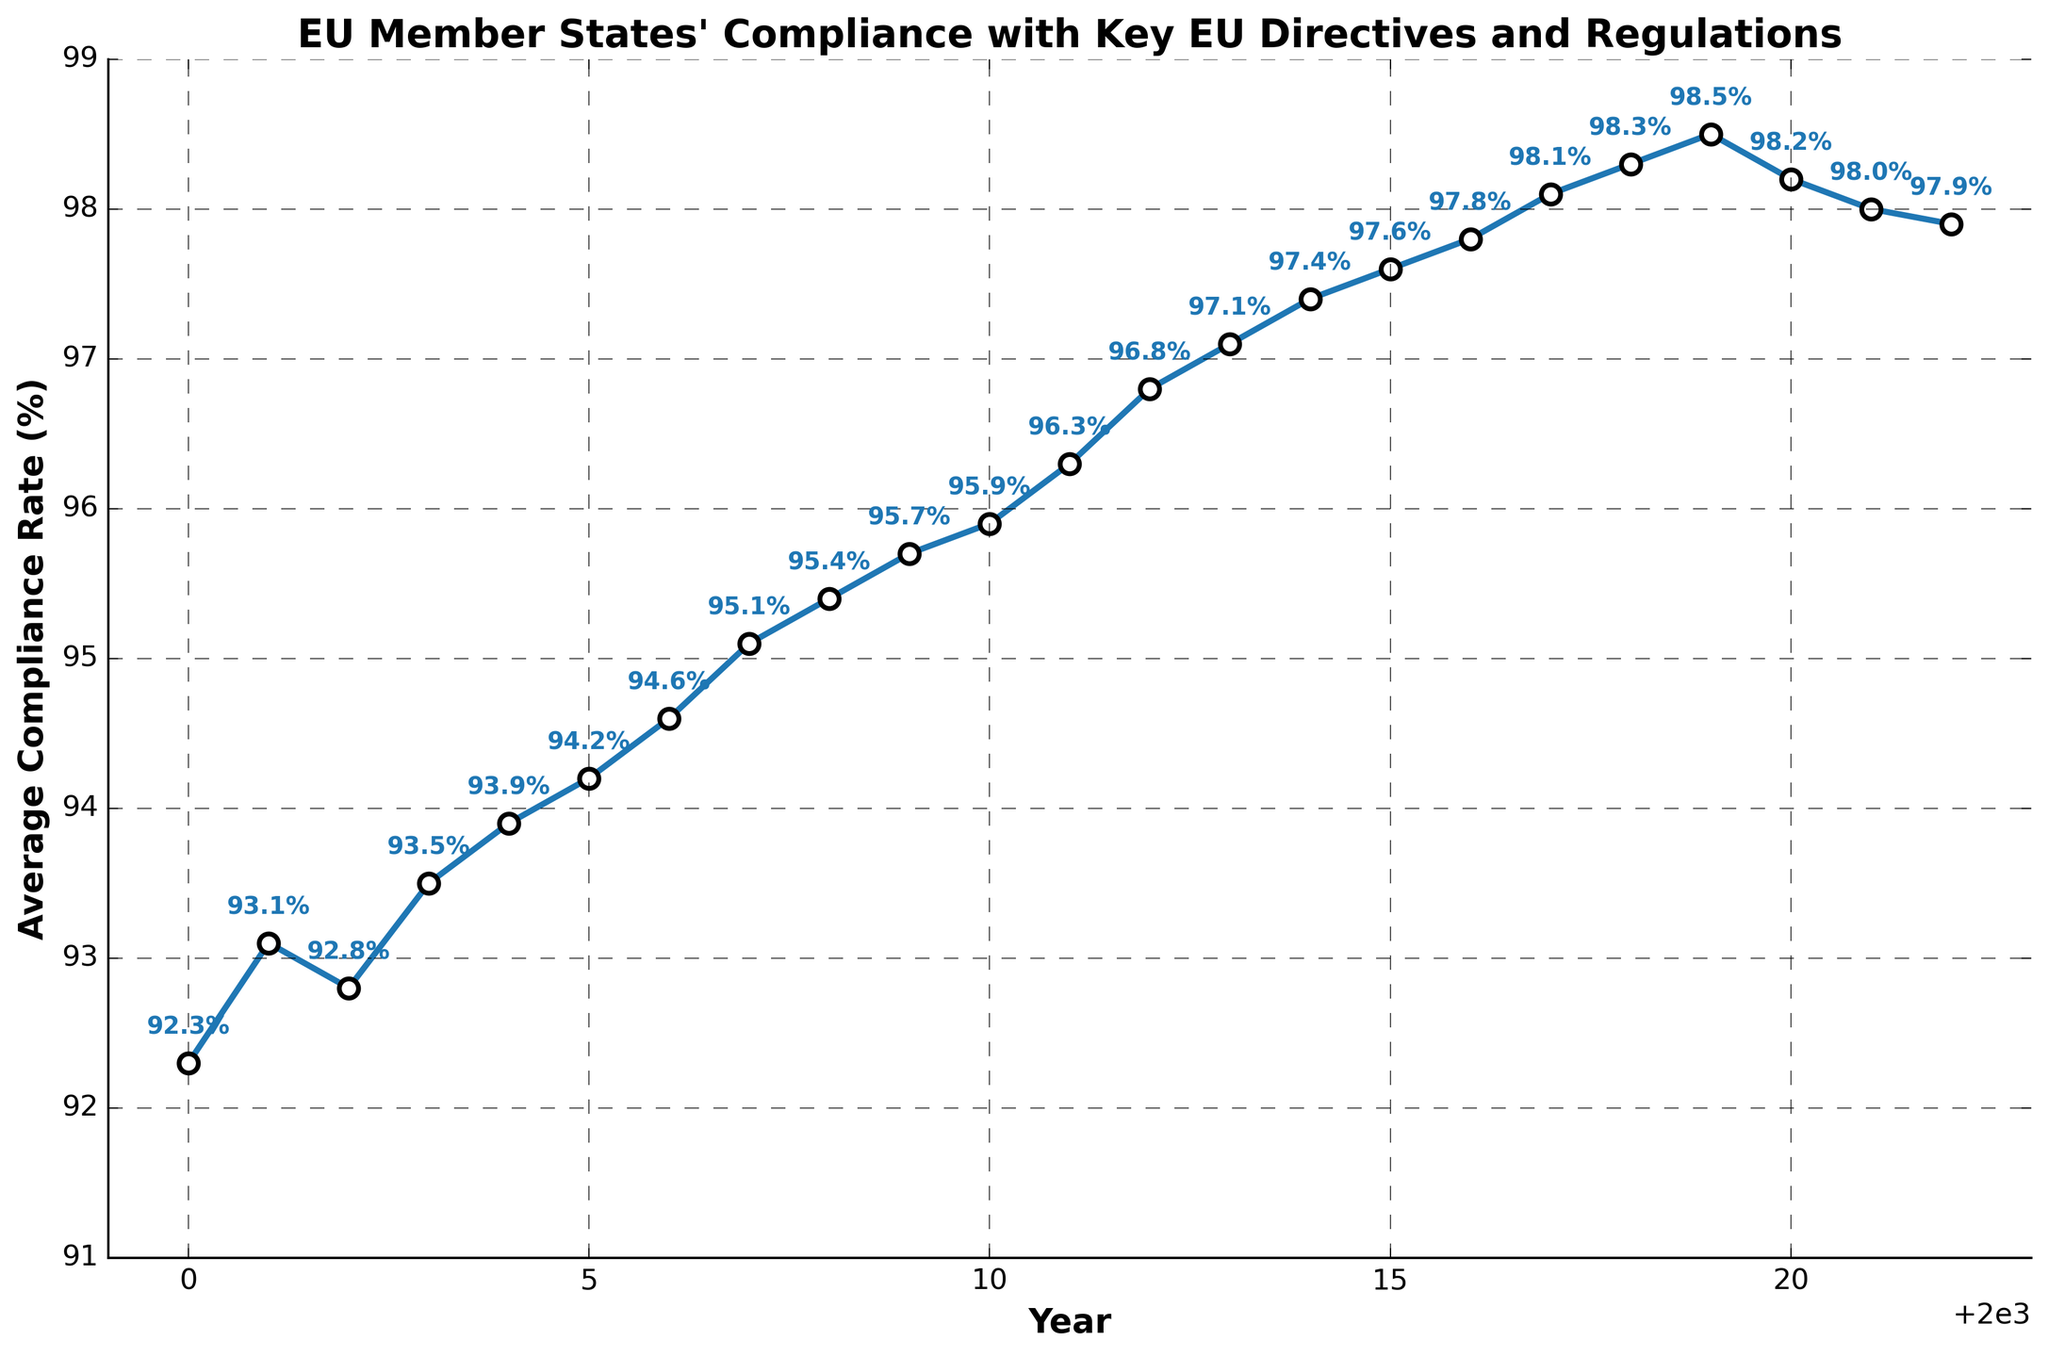What is the compliance rate in the year 2015? To find the compliance rate for the year 2015, we simply look at the data point corresponding to this year on the x-axis. The annotation next to the point reads "97.6%".
Answer: 97.6% Which year had the highest compliance rate and what was it? To determine the highest compliance rate, we examine all the data points on the y-axis and find the highest value. The highest compliance rate is seen in the year 2019, which reads "98.5%".
Answer: 2019, 98.5% How did the compliance rate change from 2000 to 2022? To understand the change, we subtract the compliance rate in 2000 from the compliance rate in 2022. The compliance rate in 2000 was 92.3%, and it was 97.9% in 2022. The change is 97.9% - 92.3% = 5.6%.
Answer: Increased by 5.6% Was there any year the compliance rate decreased compared to the previous year? By examining the plot, we can see that between 2019 and 2020, the compliance rate decreased from 98.5% to 98.2%, and again between 2020 and 2021 from 98.2% to 98.0%. Finally, it decreased slightly from 2021 to 2022, from 98.0% to 97.9%.
Answer: Yes What is the average compliance rate over the years shown in the plot? To find the average, sum all the compliance rate values from 2000 to 2022 and divide by the number of years. The sum is 92.3 + 93.1 + 92.8 + ... + 97.9 = 2235.4%. The number of years is 23. The average is 2235.4 / 23, which equals approximately 97.2%.
Answer: 97.2% Which year had the lowest compliance rate and what was it? To determine the lowest compliance rate, we examine all the data points on the y-axis and find the lowest value. The lowest compliance rate is seen in the year 2000, which reads "92.3%".
Answer: 2000, 92.3% Did the compliance rate ever drop below 92%? By looking at the plot, we can see that the lowest compliance rate was in the year 2000 at "92.3%". No year had a compliance rate below 92%.
Answer: No In which decade (2000-2009 or 2010-2019) did the compliance rate improve the most? We need to find the difference in the compliance rate from the start to the end of each decade. From 2000 to 2009, the difference is 95.7% - 92.3% = 3.4%. From 2010 to 2019, the difference is 98.5% - 95.9% = 2.6%. The greater improvement was in the decade 2000-2009.
Answer: 2000-2009 How many years did the compliance rate stay constant or show no change? By observing the plot, there are no instances where the compliance rate stays constant; the rate either increases or decreases each year.
Answer: 0 